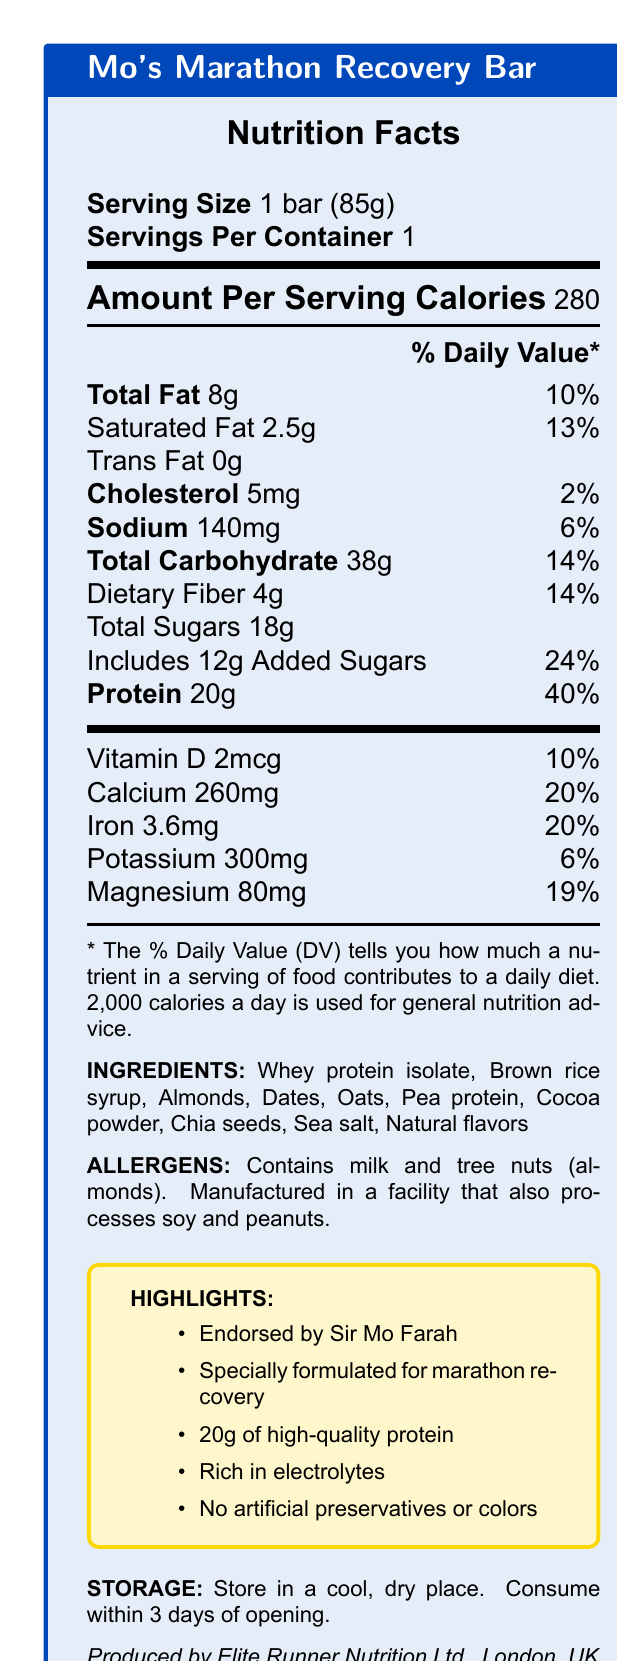what is the serving size? The serving size is indicated under the "Serving Size" section as "1 bar (85g)."
Answer: 1 bar (85g) how many calories are there per serving? Under the "Amount Per Serving" section, it specifies "Calories 280."
Answer: 280 calories what percentage of the daily value is the total fat content? The "Total Fat" content is given as 8g with a daily value of 10%.
Answer: 10% how much protein is in one bar? Under the "Protein" section, it mentions "Protein 20g."
Answer: 20g which ingredient is mentioned first on the list? The list of ingredients starts with "Whey protein isolate."
Answer: Whey protein isolate how much dietary fiber is there per serving? The "Dietary Fiber" content is specified as 4g.
Answer: 4g what is the company that produces the bar? The producer is noted at the end of the document as "Produced by Elite Runner Nutrition Ltd., London, UK."
Answer: Elite Runner Nutrition Ltd. what precaution should someone with a nut allergy take? Under the "ALLERGENS" section, it mentions "Contains milk and tree nuts (almonds)" and "Manufactured in a facility that also processes soy and peanuts."
Answer: Avoid consuming due to tree nuts (almonds) what are the marketing claims of the bar? Under the "HIGHLIGHTS" section, it lists several marketing claims including "Endorsed by Sir Mo Farah."
Answer: Endorsed by Sir Mo Farah; Specially formulated for marathon recovery; 20g of high-quality protein; Rich in electrolytes; No artificial preservatives or colors when should this bar be consumed after opening? The "STORAGE" section specifies to "Consume within 3 days of opening."
Answer: Within 3 days how much calcium does one bar provide? A. 10% of daily value B. 20% of daily value C. 6% of daily value D. 13% of daily value Under the vitamins and minerals section, it states "Calcium 260mg 20%."
Answer: B which of the following is NOT an ingredient in the bar? A. Almonds B. Honey C. Oats D. Dates The list of ingredients does not include "Honey."
Answer: B is the bar rich in electrolytes? The marketing claims highlight that the bar is "Rich in electrolytes."
Answer: Yes is there any artificial preservative in the bar? One of the marketing claims mentions "No artificial preservatives or colors."
Answer: No does the bar contain any trans fat? Under "Saturated Fat," it explicitly lists "Trans Fat 0g."
Answer: No summarize the main features of "Mo's Marathon Recovery Bar." The summary encapsulates key features related to nutrition, ingredients, endorsements, and special characteristics.
Answer: Mo's Marathon Recovery Bar is a nutritional protein bar designed for post-marathon recovery, endorsed by Sir Mo Farah. It contains 280 calories per serving, with 20g of protein, and is rich in electrolytes and essential minerals. The bar includes natural ingredients like whey protein isolate, almonds, and dates, without artificial preservatives or colors. It also includes specific storage instructions and allergen warnings. what is the percentage of daily value for iron content? The document states "Iron 3.6mg 20%" under the vitamins and minerals section.
Answer: 20% what is the serving size for multiple servings per container? The document states "Servings Per Container 1," so it does not provide information for a situation with multiple servings per container.
Answer: Not enough information who endorses Mo's Marathon Recovery Bar? The highlights section includes the claim "Endorsed by Sir Mo Farah."
Answer: Sir Mo Farah what amount of added sugars is in the bar? Under the "Total Sugars" section, it indicates "Includes 12g Added Sugars."
Answer: 12g how many ingredients are used in the bar? Counting the ingredients listed gives a total of 10.
Answer: 10 